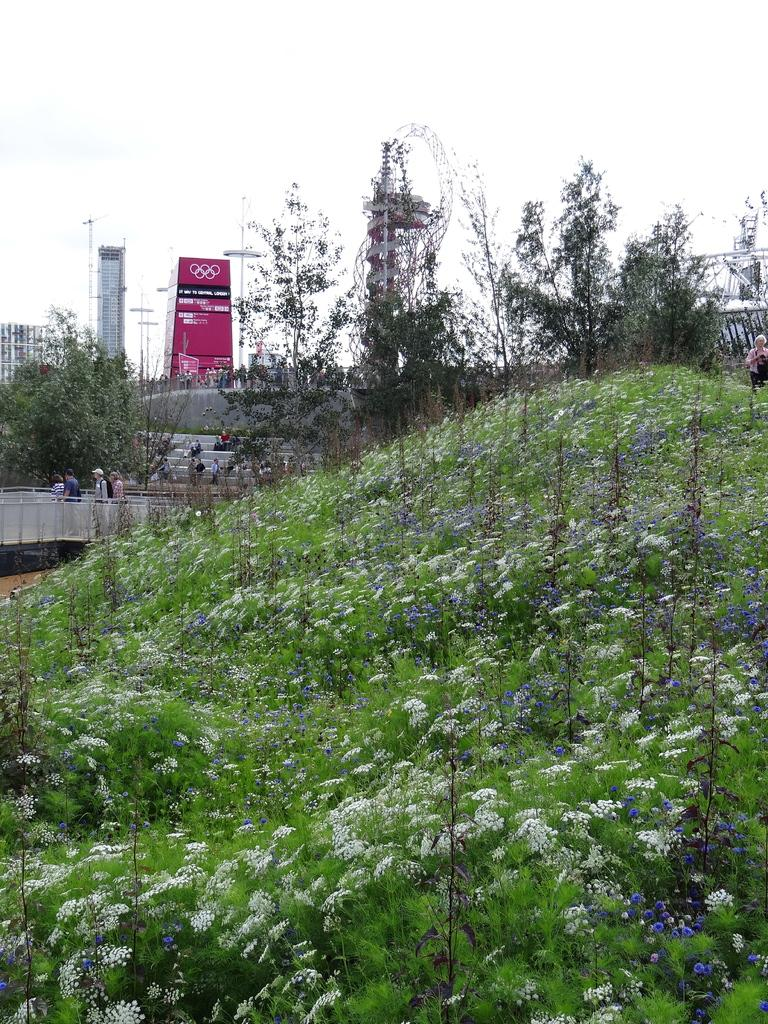What type of vegetation is present on the ground in the image? There are plants on the ground in the image. What can be seen in the background of the image? There are trees and the sky visible in the background of the image. Can you see a volleyball being played in the image? There is no volleyball or any indication of a game being played in the image. 